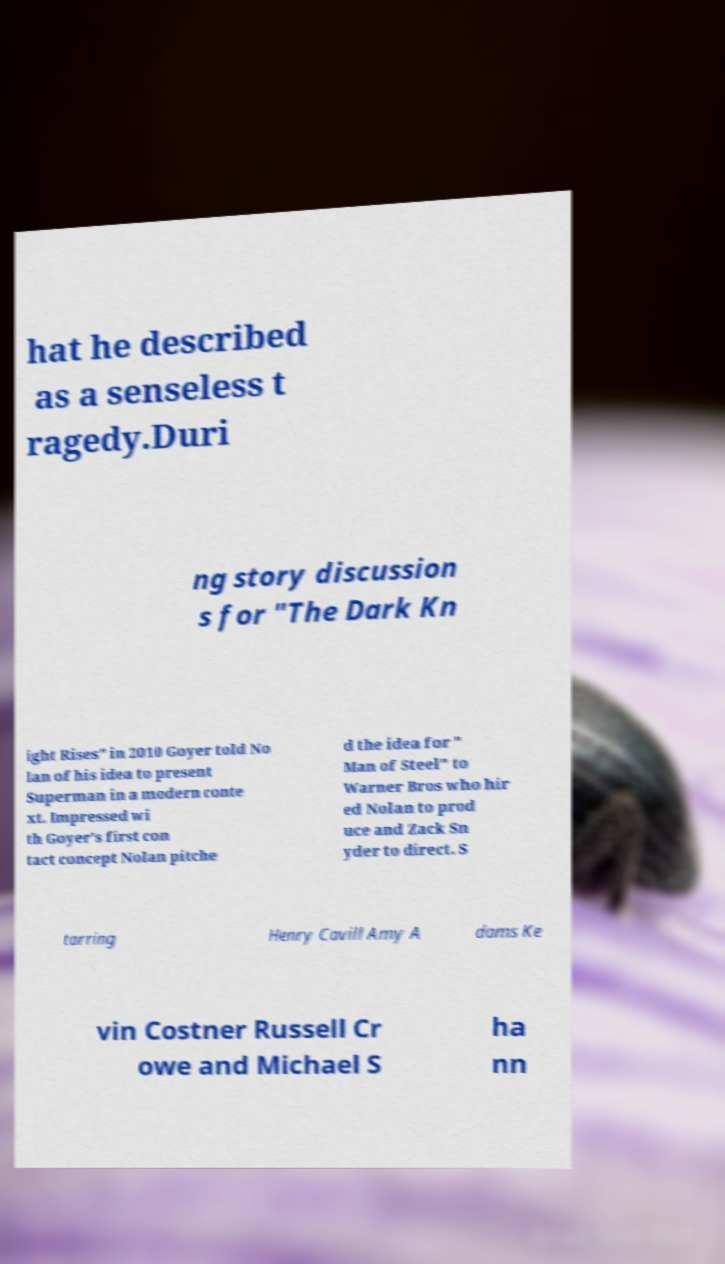Could you extract and type out the text from this image? hat he described as a senseless t ragedy.Duri ng story discussion s for "The Dark Kn ight Rises" in 2010 Goyer told No lan of his idea to present Superman in a modern conte xt. Impressed wi th Goyer's first con tact concept Nolan pitche d the idea for " Man of Steel" to Warner Bros who hir ed Nolan to prod uce and Zack Sn yder to direct. S tarring Henry Cavill Amy A dams Ke vin Costner Russell Cr owe and Michael S ha nn 